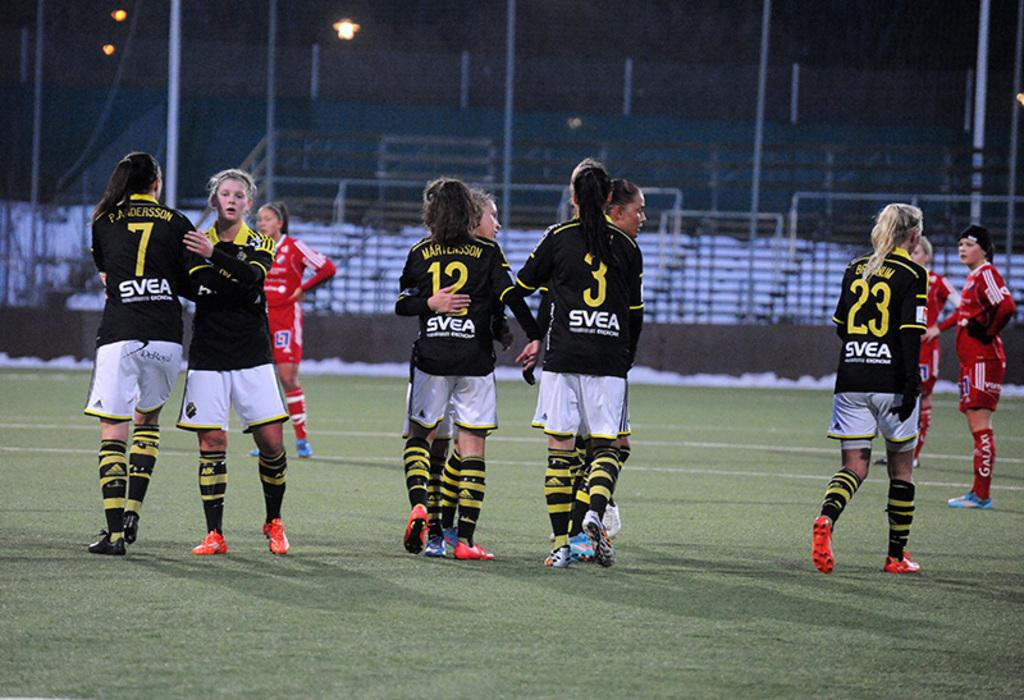<image>
Relay a brief, clear account of the picture shown. A player with a black shirt and 23 in yellow is walking on the field. 